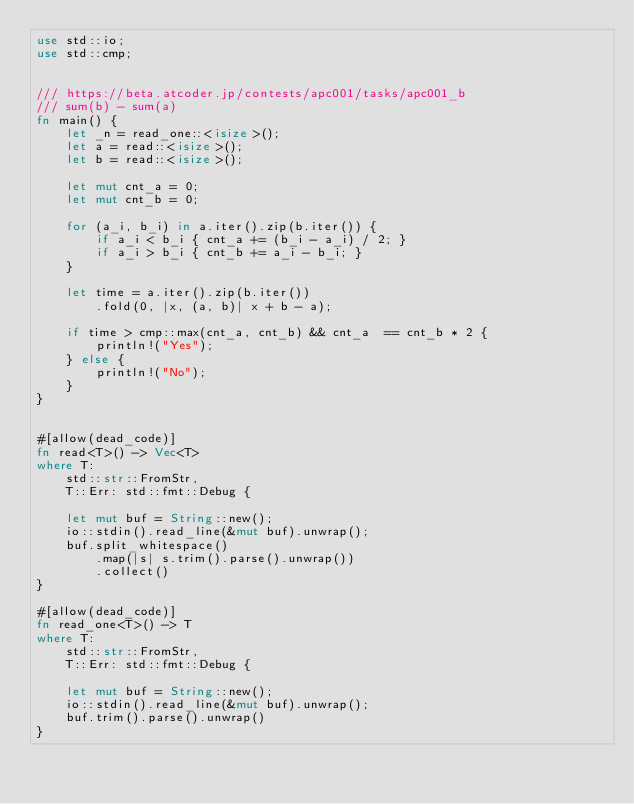<code> <loc_0><loc_0><loc_500><loc_500><_Rust_>use std::io;
use std::cmp;


/// https://beta.atcoder.jp/contests/apc001/tasks/apc001_b
/// sum(b) - sum(a)
fn main() {
    let _n = read_one::<isize>();
    let a = read::<isize>();
    let b = read::<isize>();

    let mut cnt_a = 0;
    let mut cnt_b = 0;

    for (a_i, b_i) in a.iter().zip(b.iter()) {
        if a_i < b_i { cnt_a += (b_i - a_i) / 2; }
        if a_i > b_i { cnt_b += a_i - b_i; }
    }

    let time = a.iter().zip(b.iter())
        .fold(0, |x, (a, b)| x + b - a);

    if time > cmp::max(cnt_a, cnt_b) && cnt_a  == cnt_b * 2 {
        println!("Yes");
    } else {
        println!("No");
    }
}


#[allow(dead_code)]
fn read<T>() -> Vec<T>
where T:
    std::str::FromStr,
    T::Err: std::fmt::Debug {

    let mut buf = String::new();
    io::stdin().read_line(&mut buf).unwrap();
    buf.split_whitespace()
        .map(|s| s.trim().parse().unwrap())
        .collect()
}

#[allow(dead_code)]
fn read_one<T>() -> T
where T:
    std::str::FromStr,
    T::Err: std::fmt::Debug {

    let mut buf = String::new();
    io::stdin().read_line(&mut buf).unwrap();
    buf.trim().parse().unwrap()
}</code> 